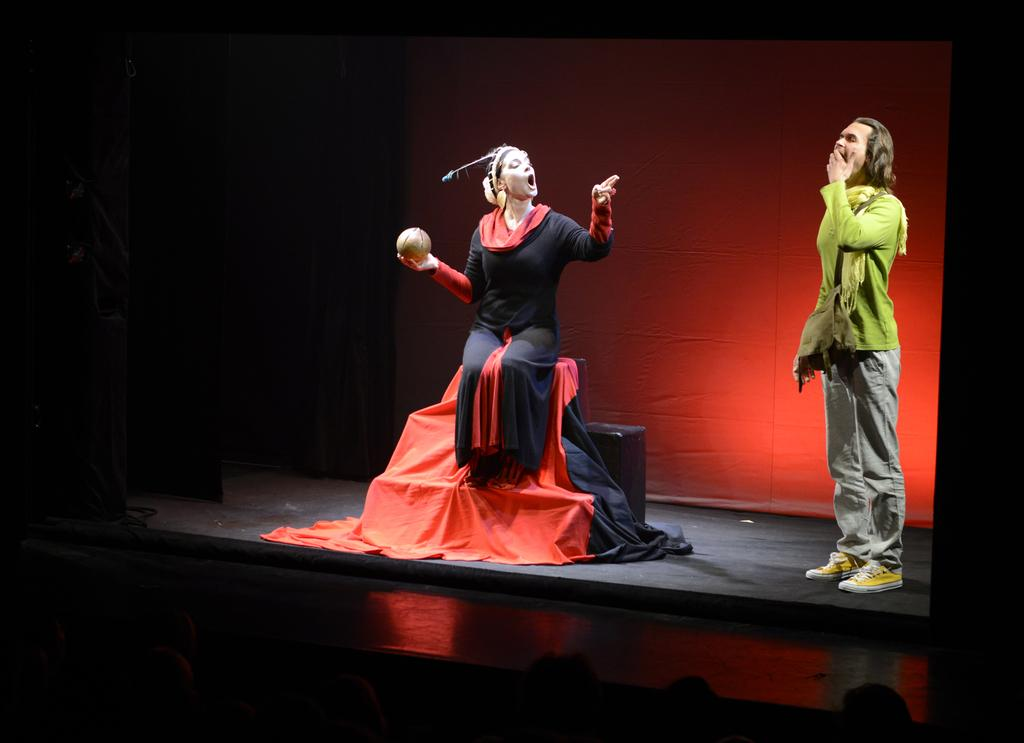Who is present in the image? There is a boy and a girl in the image. Where are the boy and girl located in the image? Both the boy and the girl are on a stage. What are they doing on the stage? They are playing an act on the stage. What type of jeans is the girl wearing in the image? There is no mention of jeans in the image, so it cannot be determined what type the girl might be wearing. 